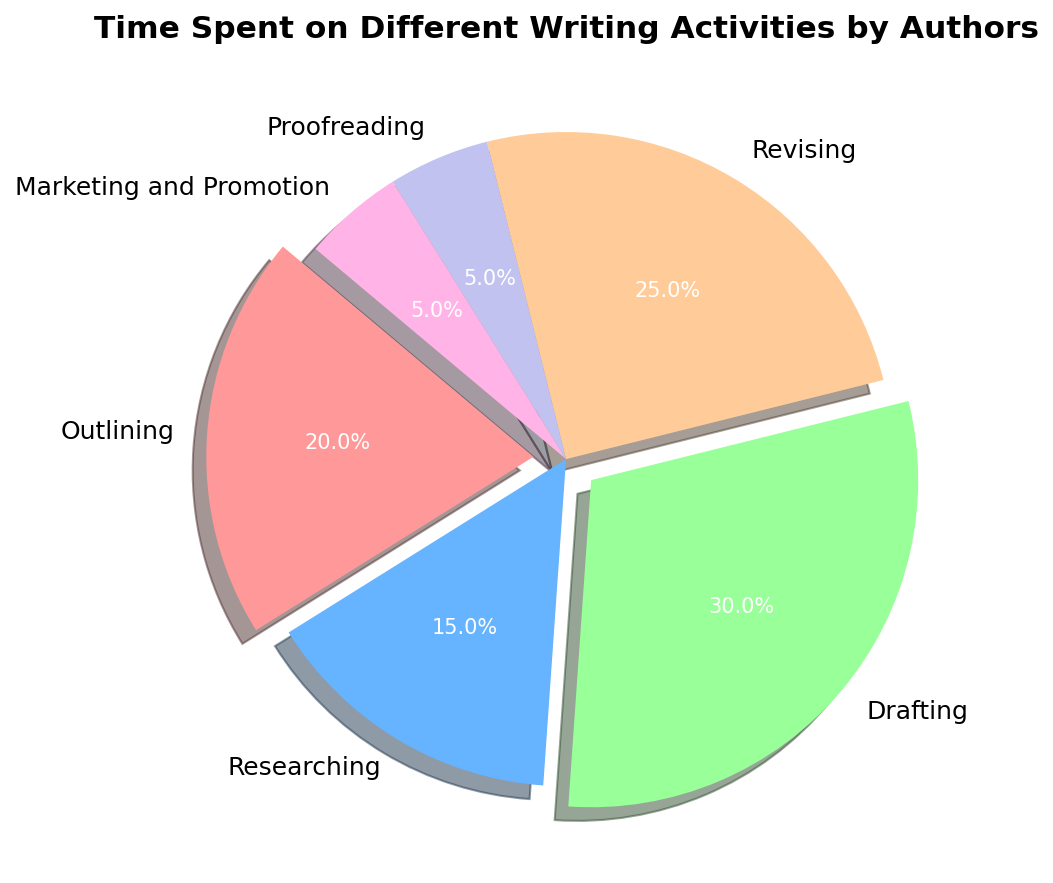What's the percentage of time spent on Drafting compared to Revising? To find this, note the percentage of time spent Drafting is 30% and Revising is 25%.
Answer: Drafting: 30%, Revising: 25% Which activity has the smallest percentage of time spent, and what is that percentage? From the pie chart, Proofreading and Marketing and Promotion each have the smallest percentage of time spent at 5%.
Answer: Proofreading and Marketing and Promotion: 5% What is the combined percentage of time spent on Researching and Outlining? The percentages for Researching and Outlining are 15% and 20% respectively. Adding these together, 15% + 20% = 35%.
Answer: 35% Which activity is represented by the light green color in the pie chart? The light green color corresponds to the activity with 30% time spent, which is Drafting.
Answer: Drafting By how much does the time spent on Revising exceed the time spent on Marketing and Promotion? Revising accounts for 25% and Marketing and Promotion account for 5%. The difference is 25% - 5% = 20%.
Answer: 20% What is the average percentage of time spent on Outlining and Researching? The percentages are 20% for Outlining and 15% for Researching. The average is (20% + 15%) / 2 = 17.5%.
Answer: 17.5% Which two activities have the same percentage of time spent in the chart? Proofreading and Marketing and Promotion both have 5% of time spent.
Answer: Proofreading and Marketing and Promotion What is the total percentage of time spent on activities other than Drafting? Subtracting the Drafting percentage from 100%: 100% - 30% = 70%. Alternatively, summing all other activities: 20% + 15% + 25% + 5% + 5% = 70%.
Answer: 70% Which activity is highlighted (exploded) along with Drafting in the pie chart? The exploded slices are highlighted to draw attention, and along with Drafting, Outlining is also highlighted.
Answer: Outlining What's the total percentage of time spent on Proofreading and Outlining combined? Proofreading and Outlining have percentages of 5% and 20% respectively. Adding these together gives us 5% + 20% = 25%.
Answer: 25% 